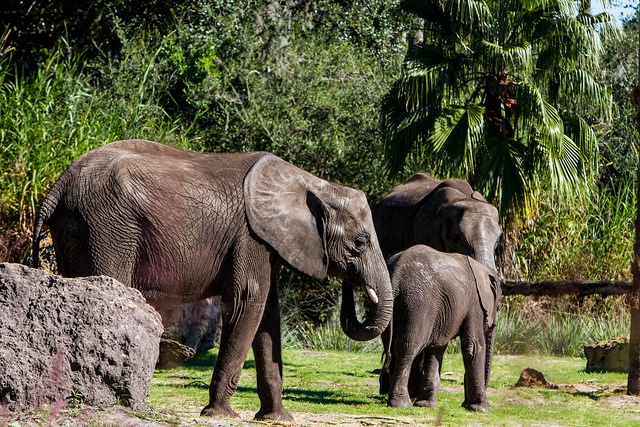Describe the objects in this image and their specific colors. I can see elephant in black, gray, and darkgray tones, elephant in black, gray, and darkgray tones, and elephant in black, darkgray, and gray tones in this image. 